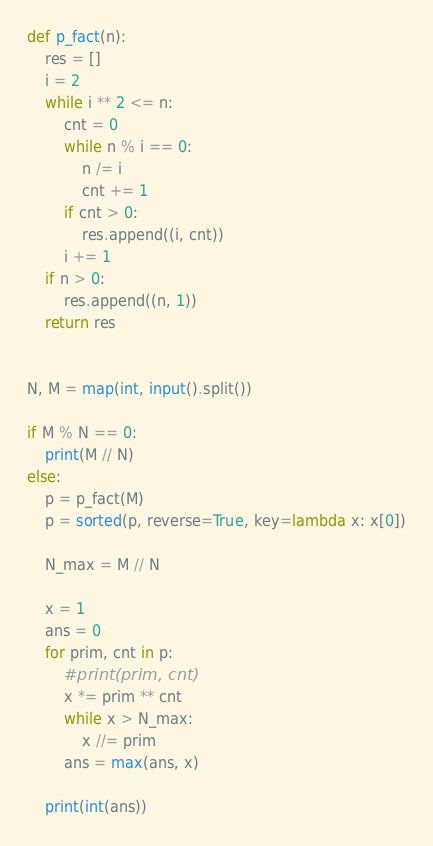Convert code to text. <code><loc_0><loc_0><loc_500><loc_500><_Python_>def p_fact(n):
    res = []
    i = 2
    while i ** 2 <= n:
        cnt = 0
        while n % i == 0:
            n /= i
            cnt += 1
        if cnt > 0:
            res.append((i, cnt))
        i += 1
    if n > 0:
        res.append((n, 1))
    return res


N, M = map(int, input().split())

if M % N == 0:
    print(M // N)
else:
    p = p_fact(M)
    p = sorted(p, reverse=True, key=lambda x: x[0])

    N_max = M // N

    x = 1
    ans = 0
    for prim, cnt in p:
        #print(prim, cnt)
        x *= prim ** cnt
        while x > N_max:
            x //= prim
        ans = max(ans, x)
        
    print(int(ans))
</code> 